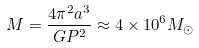<formula> <loc_0><loc_0><loc_500><loc_500>M = \frac { 4 \pi ^ { 2 } a ^ { 3 } } { G P ^ { 2 } } \approx 4 \times 1 0 ^ { 6 } M _ { \odot }</formula> 